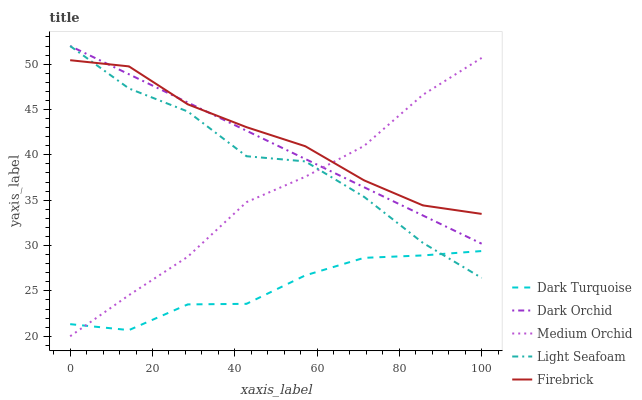Does Firebrick have the minimum area under the curve?
Answer yes or no. No. Does Dark Turquoise have the maximum area under the curve?
Answer yes or no. No. Is Dark Turquoise the smoothest?
Answer yes or no. No. Is Dark Turquoise the roughest?
Answer yes or no. No. Does Dark Turquoise have the lowest value?
Answer yes or no. No. Does Firebrick have the highest value?
Answer yes or no. No. Is Dark Turquoise less than Firebrick?
Answer yes or no. Yes. Is Firebrick greater than Dark Turquoise?
Answer yes or no. Yes. Does Dark Turquoise intersect Firebrick?
Answer yes or no. No. 